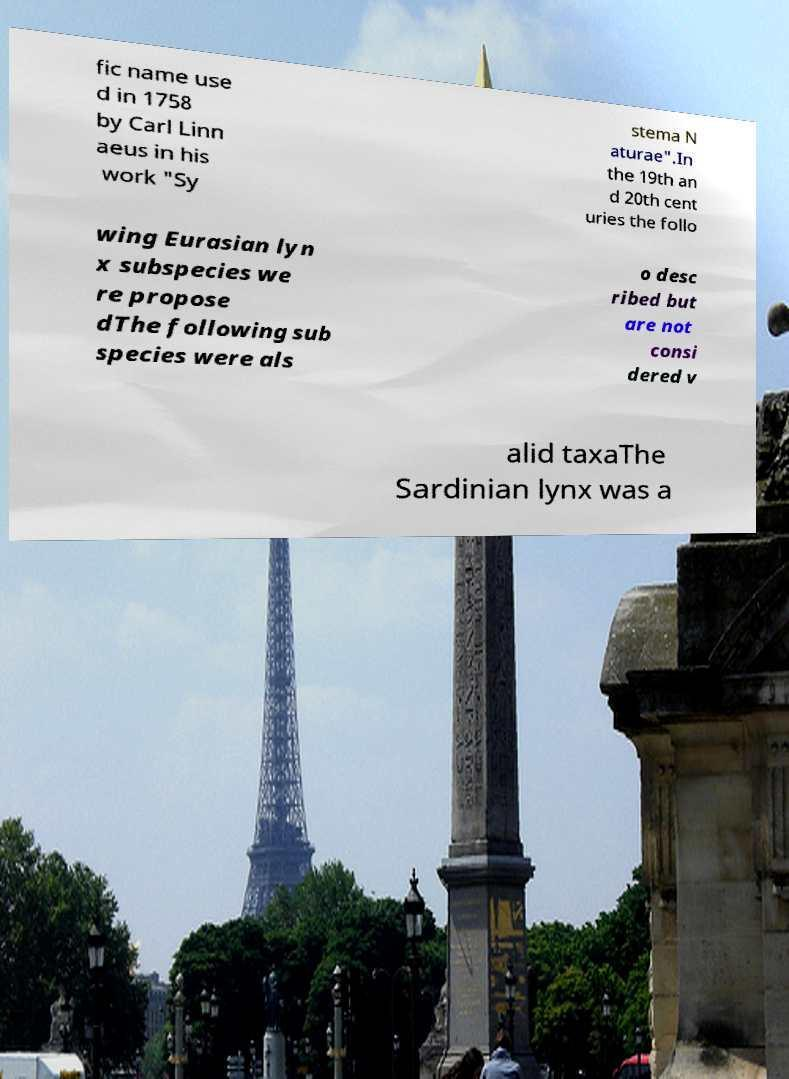Please identify and transcribe the text found in this image. fic name use d in 1758 by Carl Linn aeus in his work "Sy stema N aturae".In the 19th an d 20th cent uries the follo wing Eurasian lyn x subspecies we re propose dThe following sub species were als o desc ribed but are not consi dered v alid taxaThe Sardinian lynx was a 